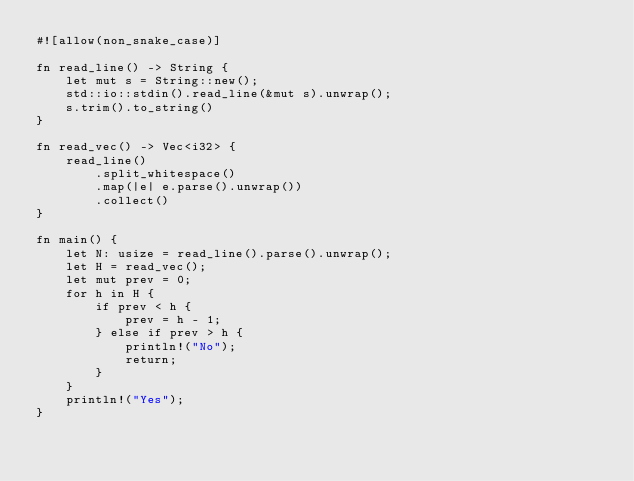<code> <loc_0><loc_0><loc_500><loc_500><_Rust_>#![allow(non_snake_case)]

fn read_line() -> String {
    let mut s = String::new();
    std::io::stdin().read_line(&mut s).unwrap();
    s.trim().to_string()
}

fn read_vec() -> Vec<i32> {
    read_line()
        .split_whitespace()
        .map(|e| e.parse().unwrap())
        .collect()
}

fn main() {
    let N: usize = read_line().parse().unwrap();
    let H = read_vec();
    let mut prev = 0;
    for h in H {
        if prev < h {
            prev = h - 1;
        } else if prev > h {
            println!("No");
            return;
        }
    }
    println!("Yes");
}
</code> 